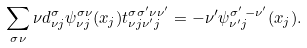Convert formula to latex. <formula><loc_0><loc_0><loc_500><loc_500>\sum _ { \sigma \nu } { \nu } d _ { \nu j } ^ { \sigma } \psi _ { \nu j } ^ { \sigma \nu } ( x _ { j } ) t _ { \nu j \nu ^ { \prime } j } ^ { \sigma \sigma ^ { \prime } \nu \nu ^ { \prime } } = - \nu ^ { \prime } \psi _ { \nu ^ { \prime } j } ^ { \sigma ^ { \prime } \, - \nu ^ { \prime } } ( x _ { j } ) .</formula> 